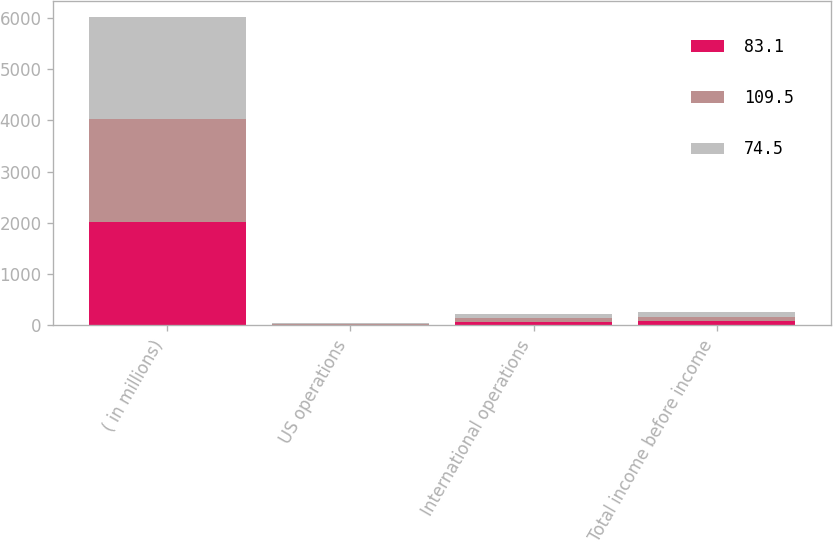Convert chart to OTSL. <chart><loc_0><loc_0><loc_500><loc_500><stacked_bar_chart><ecel><fcel>( in millions)<fcel>US operations<fcel>International operations<fcel>Total income before income<nl><fcel>83.1<fcel>2010<fcel>7.2<fcel>67.3<fcel>74.5<nl><fcel>109.5<fcel>2009<fcel>6.5<fcel>76.6<fcel>83.1<nl><fcel>74.5<fcel>2008<fcel>27.4<fcel>82.1<fcel>109.5<nl></chart> 